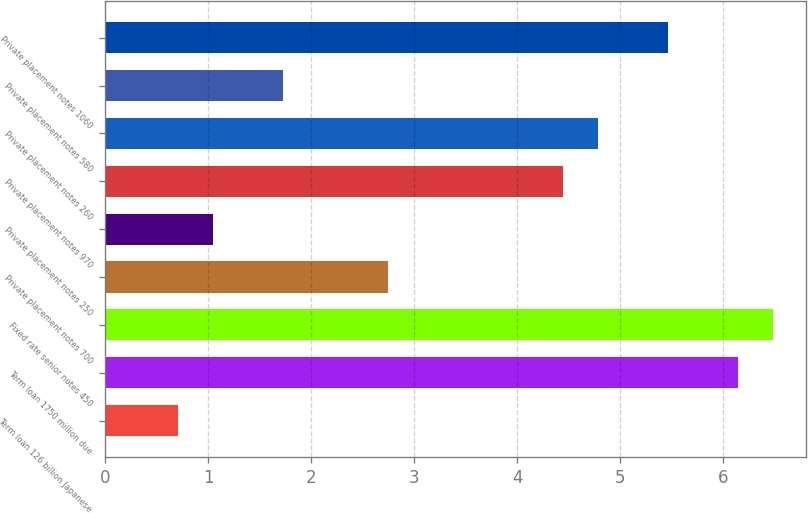Convert chart to OTSL. <chart><loc_0><loc_0><loc_500><loc_500><bar_chart><fcel>Term loan 126 billion Japanese<fcel>Term loan 1750 million due<fcel>Fixed rate senior notes 450<fcel>Private placement notes 700<fcel>Private placement notes 250<fcel>Private placement notes 970<fcel>Private placement notes 260<fcel>Private placement notes 580<fcel>Private placement notes 1060<nl><fcel>0.7<fcel>6.14<fcel>6.48<fcel>2.74<fcel>1.04<fcel>4.44<fcel>4.78<fcel>1.72<fcel>5.46<nl></chart> 